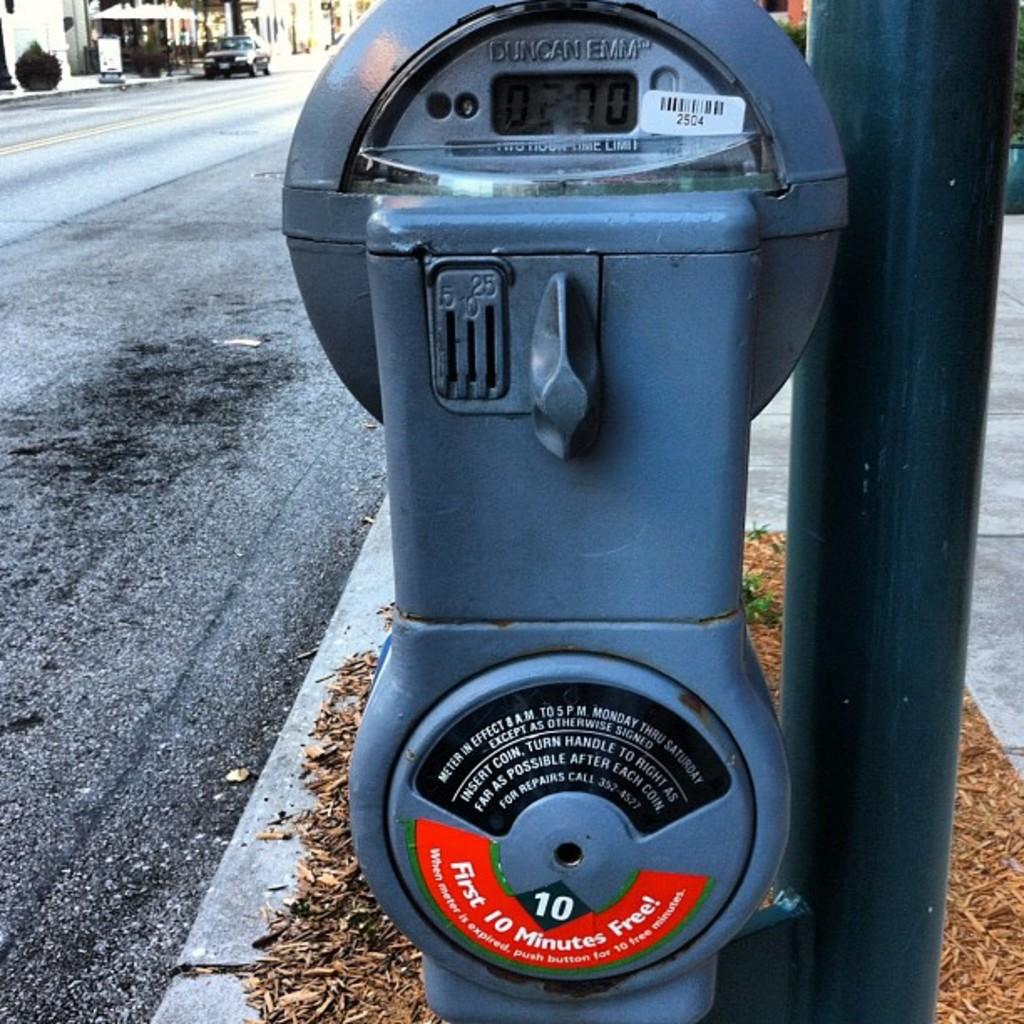First 10 minutes are what?
Provide a short and direct response. Free. What minutes is free?
Offer a terse response. First 10 minutes. 